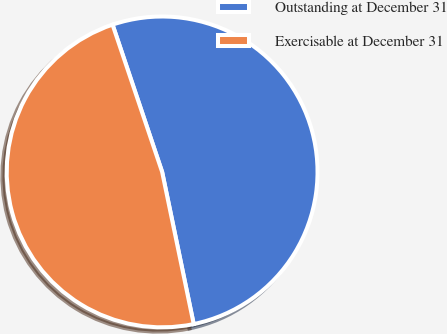Convert chart to OTSL. <chart><loc_0><loc_0><loc_500><loc_500><pie_chart><fcel>Outstanding at December 31<fcel>Exercisable at December 31<nl><fcel>51.91%<fcel>48.09%<nl></chart> 